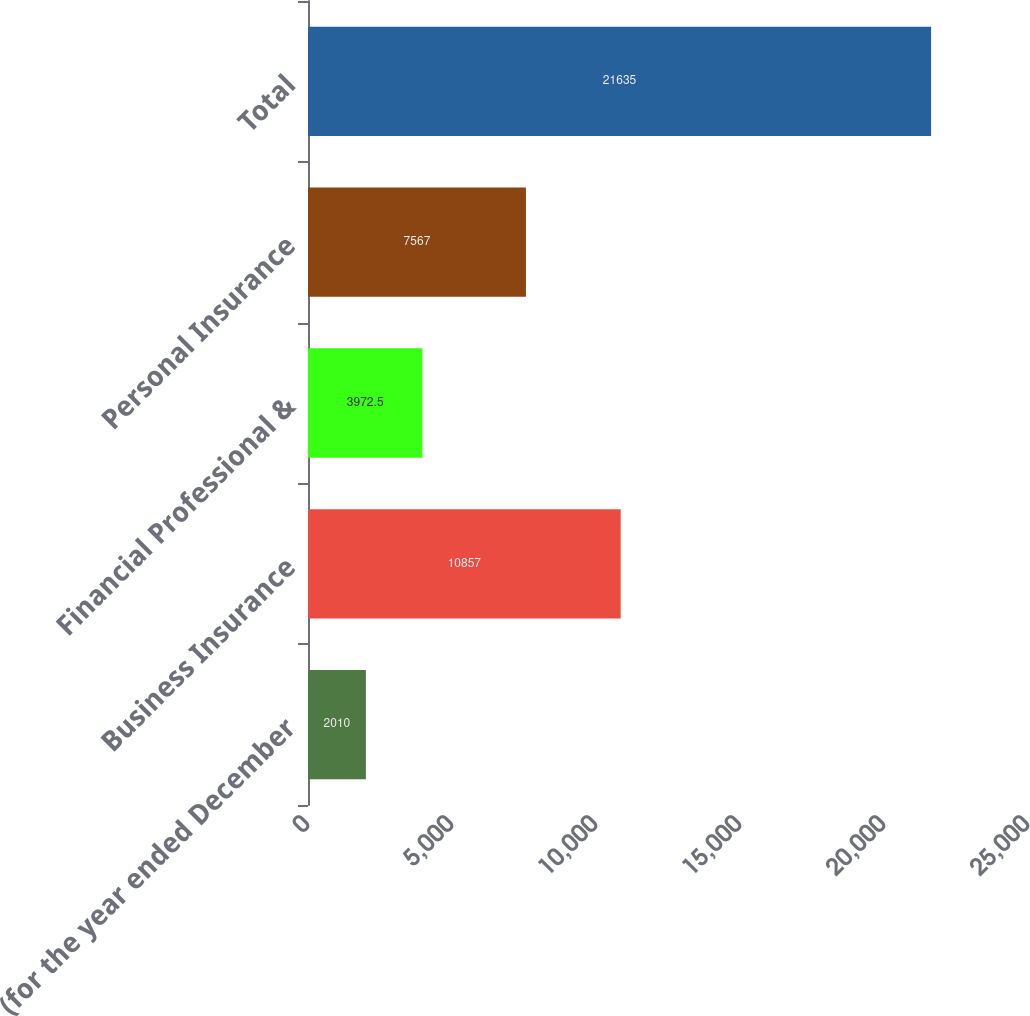<chart> <loc_0><loc_0><loc_500><loc_500><bar_chart><fcel>(for the year ended December<fcel>Business Insurance<fcel>Financial Professional &<fcel>Personal Insurance<fcel>Total<nl><fcel>2010<fcel>10857<fcel>3972.5<fcel>7567<fcel>21635<nl></chart> 